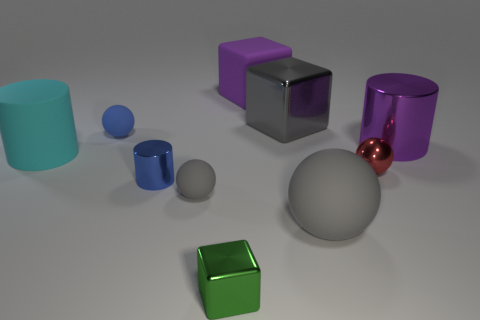What is the material of the ball behind the purple object that is right of the large gray object that is behind the purple cylinder? rubber 